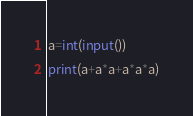<code> <loc_0><loc_0><loc_500><loc_500><_Python_>a=int(input())
print(a+a*a+a*a*a)</code> 